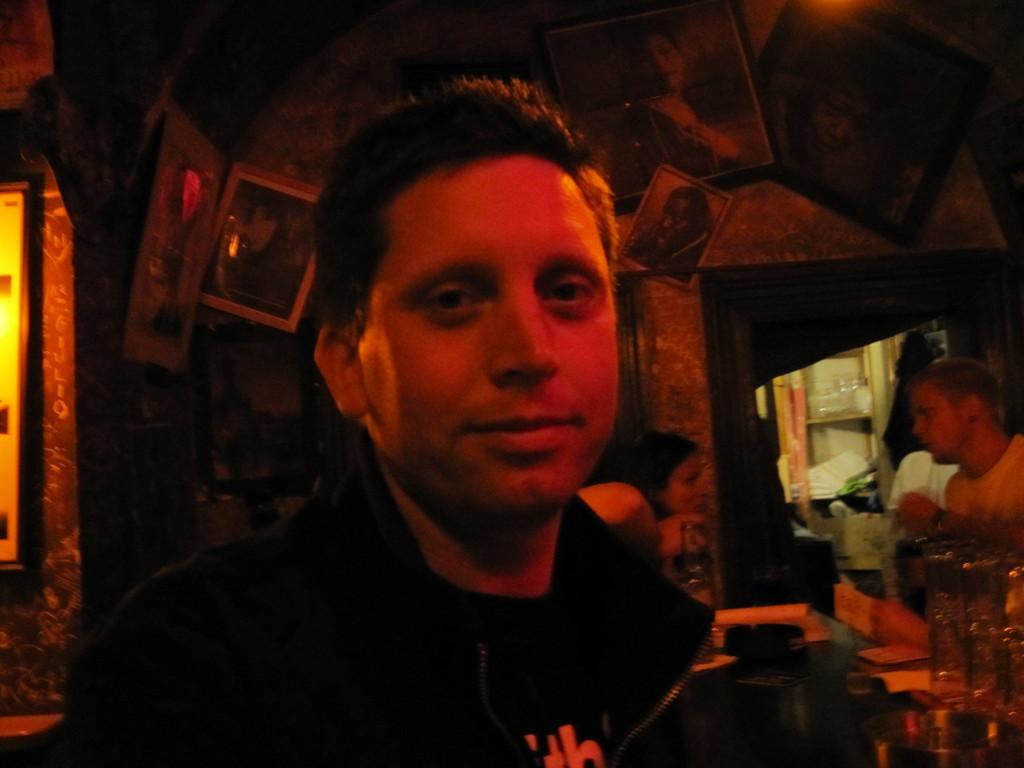In one or two sentences, can you explain what this image depicts? In the foreground of this image, there is a man. In the background, there are frames on the wall, a woman and a man standing near a desk on which there are glasses and few more objects and also there is a red color light in the background. 